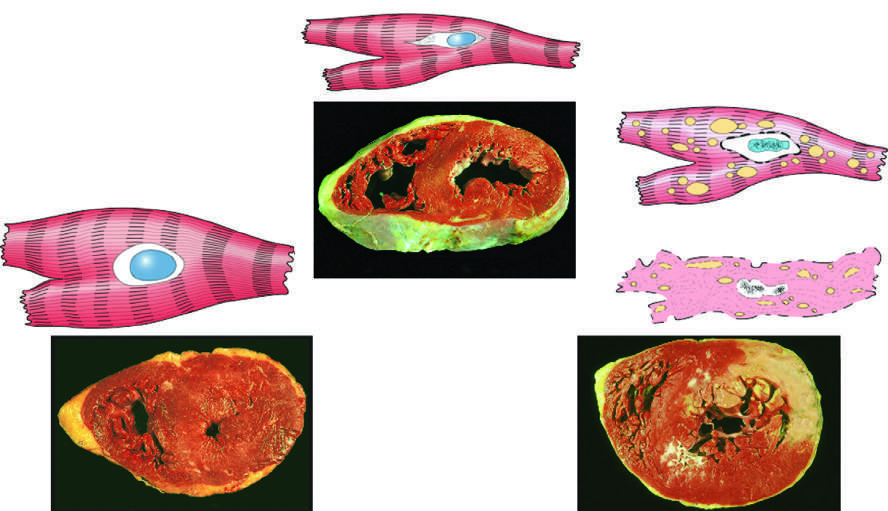s there an infarct in the brain hypertrophy?
Answer the question using a single word or phrase. No 